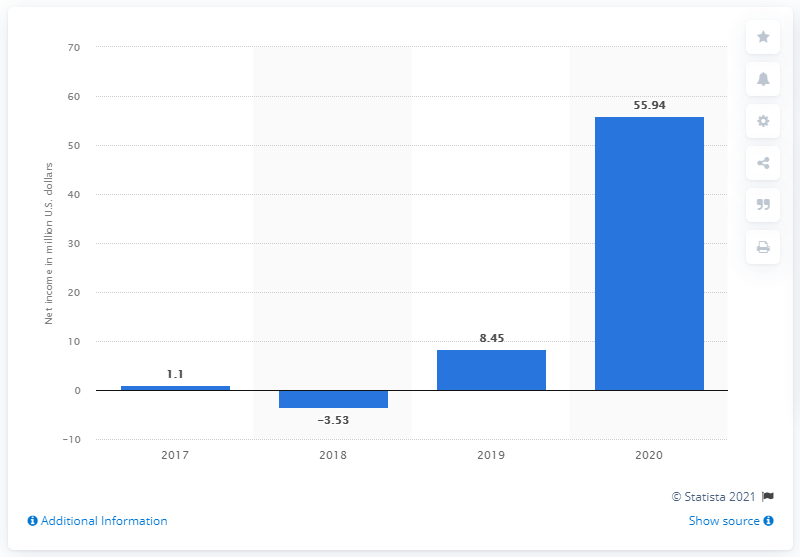Draw attention to some important aspects in this diagram. In the United States in 2020, Big 5 Sporting Goods had a net income of $55.94 million. 